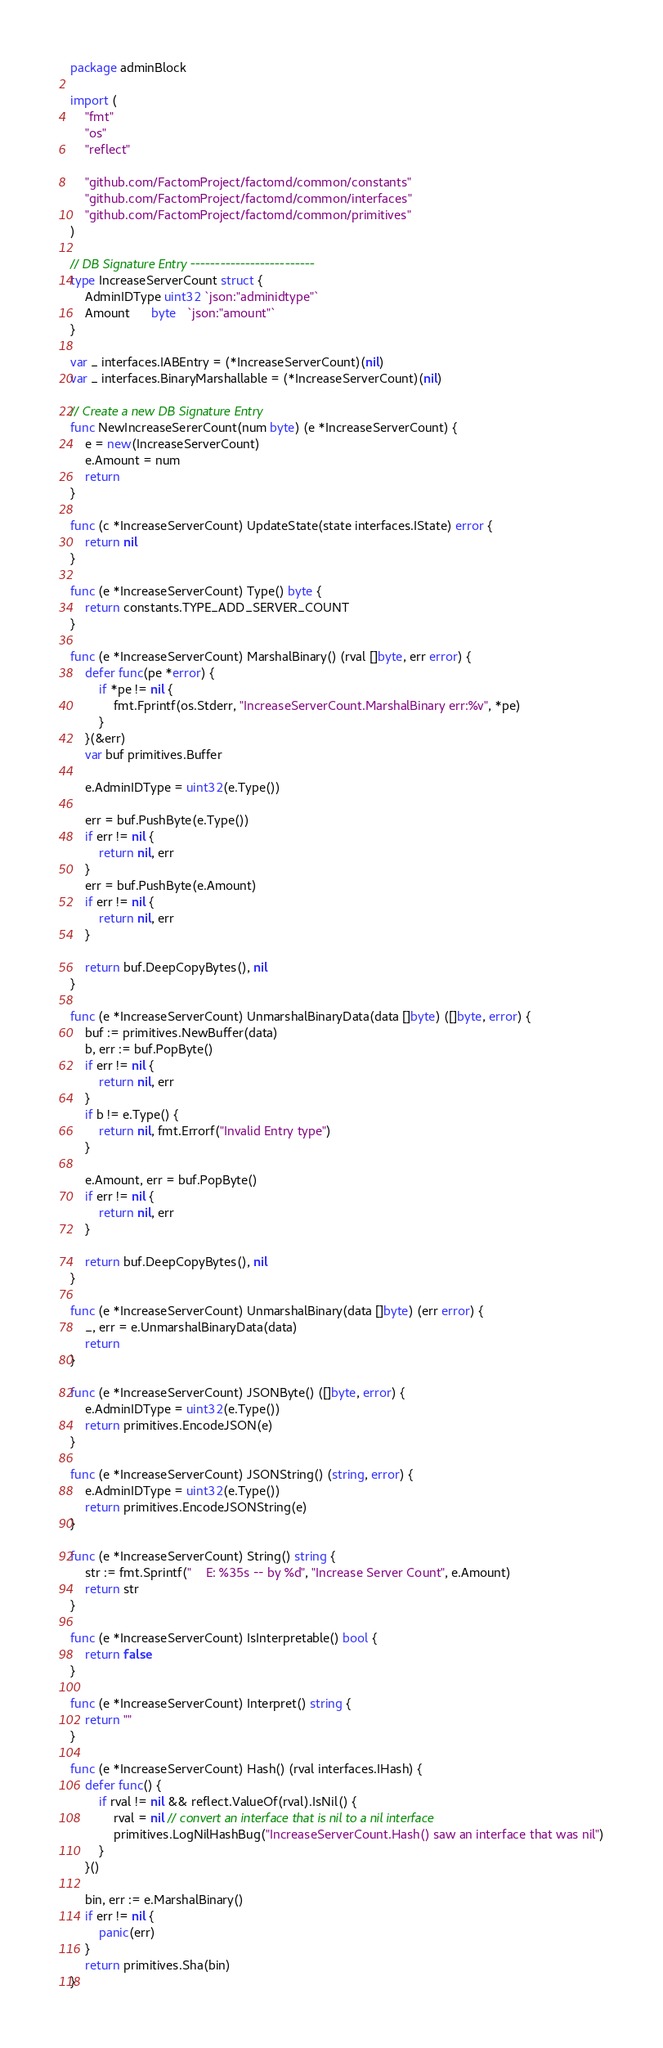Convert code to text. <code><loc_0><loc_0><loc_500><loc_500><_Go_>package adminBlock

import (
	"fmt"
	"os"
	"reflect"

	"github.com/FactomProject/factomd/common/constants"
	"github.com/FactomProject/factomd/common/interfaces"
	"github.com/FactomProject/factomd/common/primitives"
)

// DB Signature Entry -------------------------
type IncreaseServerCount struct {
	AdminIDType uint32 `json:"adminidtype"`
	Amount      byte   `json:"amount"`
}

var _ interfaces.IABEntry = (*IncreaseServerCount)(nil)
var _ interfaces.BinaryMarshallable = (*IncreaseServerCount)(nil)

// Create a new DB Signature Entry
func NewIncreaseSererCount(num byte) (e *IncreaseServerCount) {
	e = new(IncreaseServerCount)
	e.Amount = num
	return
}

func (c *IncreaseServerCount) UpdateState(state interfaces.IState) error {
	return nil
}

func (e *IncreaseServerCount) Type() byte {
	return constants.TYPE_ADD_SERVER_COUNT
}

func (e *IncreaseServerCount) MarshalBinary() (rval []byte, err error) {
	defer func(pe *error) {
		if *pe != nil {
			fmt.Fprintf(os.Stderr, "IncreaseServerCount.MarshalBinary err:%v", *pe)
		}
	}(&err)
	var buf primitives.Buffer

	e.AdminIDType = uint32(e.Type())

	err = buf.PushByte(e.Type())
	if err != nil {
		return nil, err
	}
	err = buf.PushByte(e.Amount)
	if err != nil {
		return nil, err
	}

	return buf.DeepCopyBytes(), nil
}

func (e *IncreaseServerCount) UnmarshalBinaryData(data []byte) ([]byte, error) {
	buf := primitives.NewBuffer(data)
	b, err := buf.PopByte()
	if err != nil {
		return nil, err
	}
	if b != e.Type() {
		return nil, fmt.Errorf("Invalid Entry type")
	}

	e.Amount, err = buf.PopByte()
	if err != nil {
		return nil, err
	}

	return buf.DeepCopyBytes(), nil
}

func (e *IncreaseServerCount) UnmarshalBinary(data []byte) (err error) {
	_, err = e.UnmarshalBinaryData(data)
	return
}

func (e *IncreaseServerCount) JSONByte() ([]byte, error) {
	e.AdminIDType = uint32(e.Type())
	return primitives.EncodeJSON(e)
}

func (e *IncreaseServerCount) JSONString() (string, error) {
	e.AdminIDType = uint32(e.Type())
	return primitives.EncodeJSONString(e)
}

func (e *IncreaseServerCount) String() string {
	str := fmt.Sprintf("    E: %35s -- by %d", "Increase Server Count", e.Amount)
	return str
}

func (e *IncreaseServerCount) IsInterpretable() bool {
	return false
}

func (e *IncreaseServerCount) Interpret() string {
	return ""
}

func (e *IncreaseServerCount) Hash() (rval interfaces.IHash) {
	defer func() {
		if rval != nil && reflect.ValueOf(rval).IsNil() {
			rval = nil // convert an interface that is nil to a nil interface
			primitives.LogNilHashBug("IncreaseServerCount.Hash() saw an interface that was nil")
		}
	}()

	bin, err := e.MarshalBinary()
	if err != nil {
		panic(err)
	}
	return primitives.Sha(bin)
}
</code> 